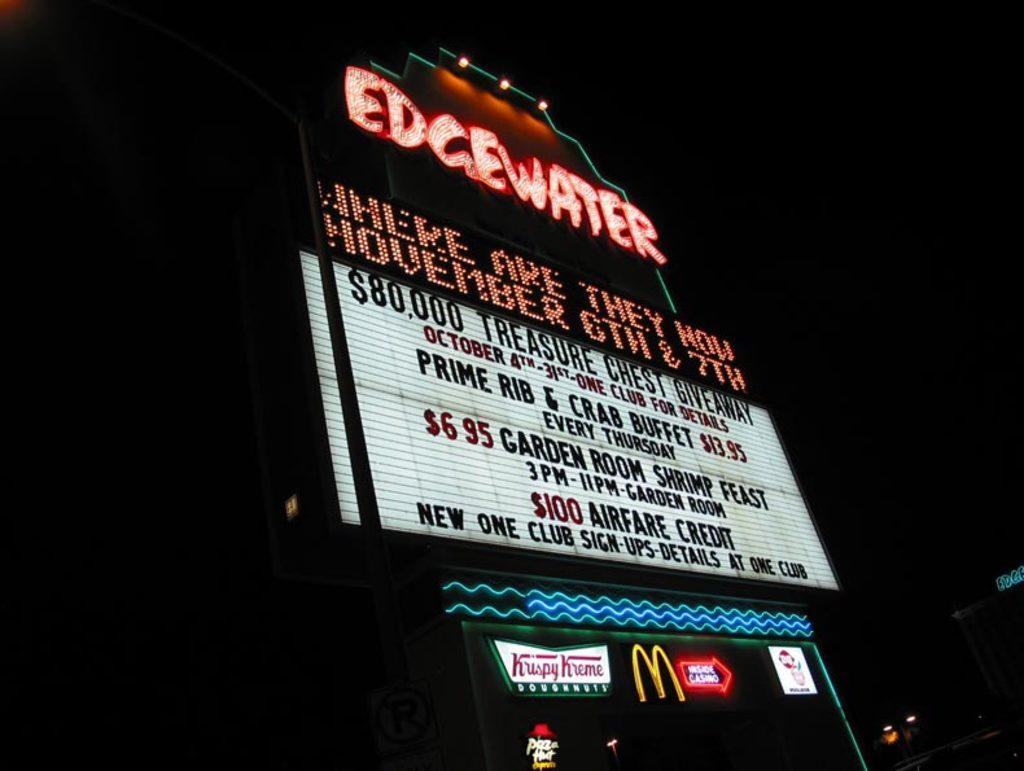<image>
Create a compact narrative representing the image presented. A neon sign at night advertises the Edgewater Bar and function room. 